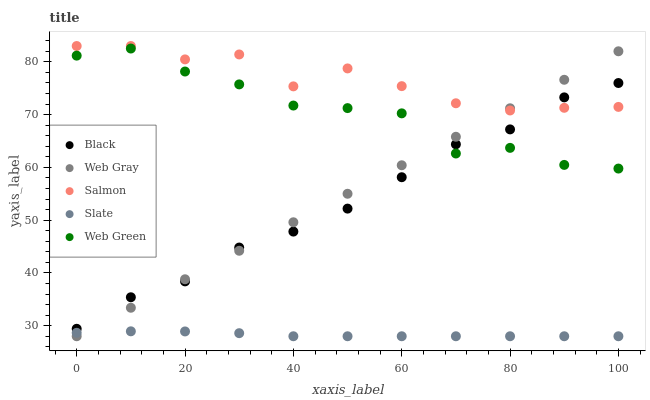Does Slate have the minimum area under the curve?
Answer yes or no. Yes. Does Salmon have the maximum area under the curve?
Answer yes or no. Yes. Does Web Gray have the minimum area under the curve?
Answer yes or no. No. Does Web Gray have the maximum area under the curve?
Answer yes or no. No. Is Web Gray the smoothest?
Answer yes or no. Yes. Is Web Green the roughest?
Answer yes or no. Yes. Is Slate the smoothest?
Answer yes or no. No. Is Slate the roughest?
Answer yes or no. No. Does Slate have the lowest value?
Answer yes or no. Yes. Does Black have the lowest value?
Answer yes or no. No. Does Salmon have the highest value?
Answer yes or no. Yes. Does Web Gray have the highest value?
Answer yes or no. No. Is Web Green less than Salmon?
Answer yes or no. Yes. Is Black greater than Slate?
Answer yes or no. Yes. Does Web Green intersect Web Gray?
Answer yes or no. Yes. Is Web Green less than Web Gray?
Answer yes or no. No. Is Web Green greater than Web Gray?
Answer yes or no. No. Does Web Green intersect Salmon?
Answer yes or no. No. 